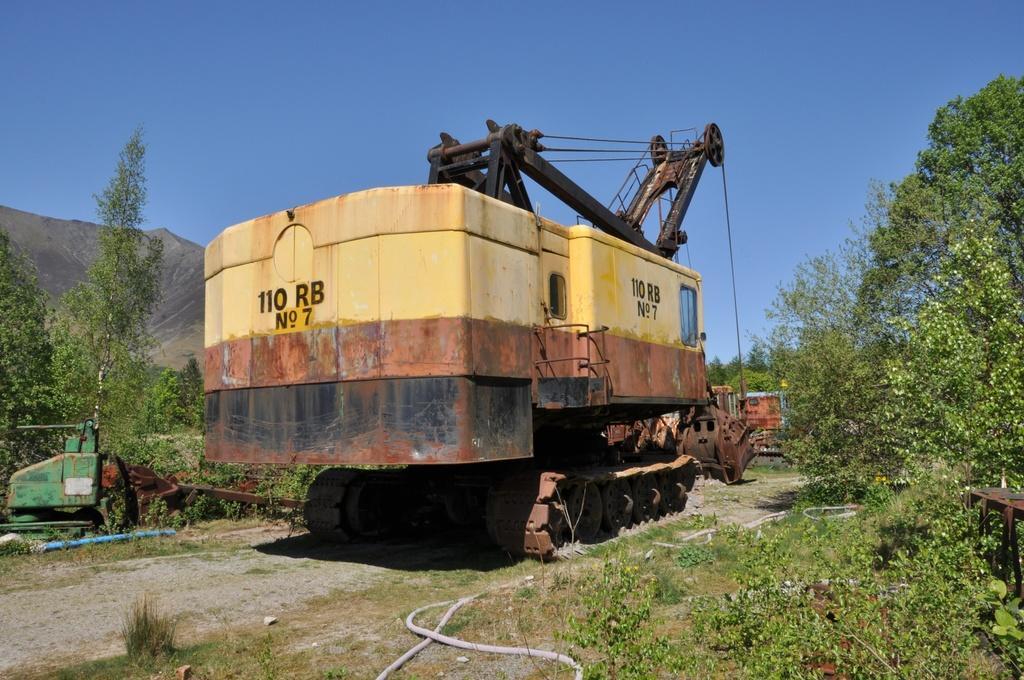In one or two sentences, can you explain what this image depicts? In this picture we can see vehicles and other objects. We can see grass, plants, trees and the sky. 